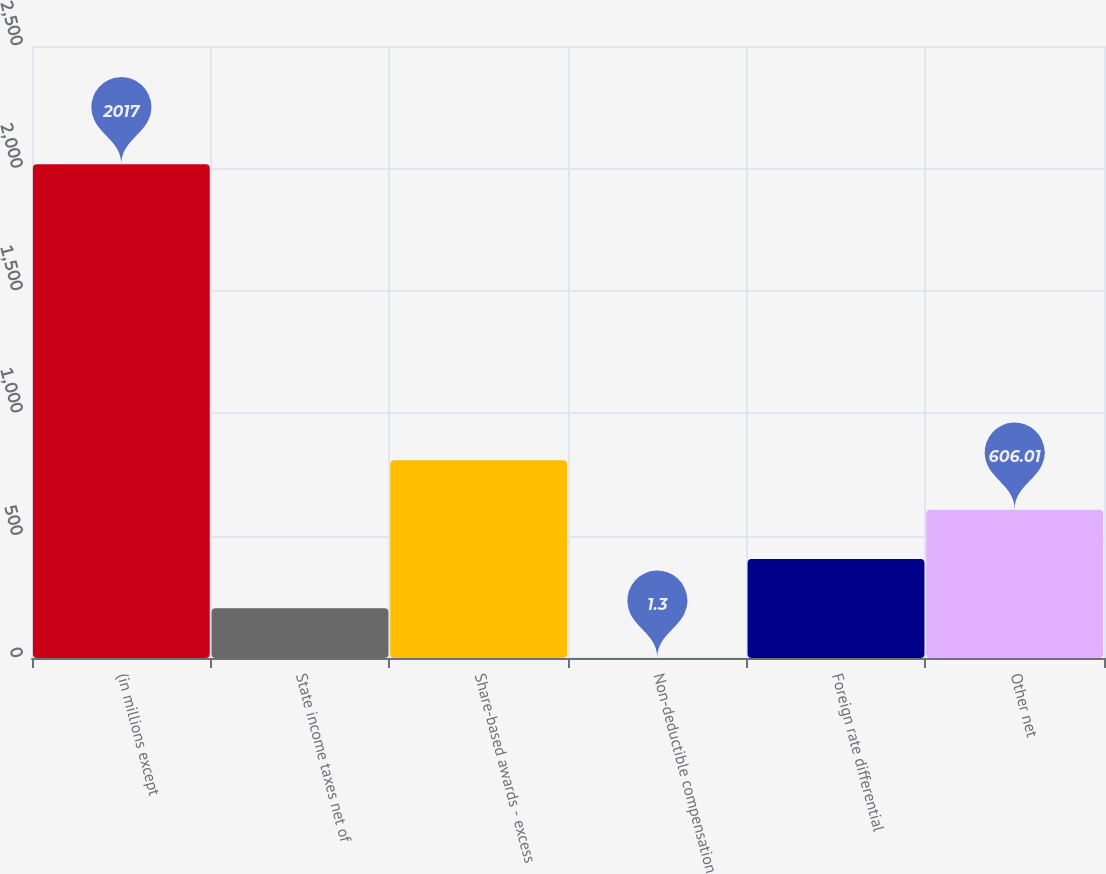Convert chart. <chart><loc_0><loc_0><loc_500><loc_500><bar_chart><fcel>(in millions except<fcel>State income taxes net of<fcel>Share-based awards - excess<fcel>Non-deductible compensation<fcel>Foreign rate differential<fcel>Other net<nl><fcel>2017<fcel>202.87<fcel>807.58<fcel>1.3<fcel>404.44<fcel>606.01<nl></chart> 